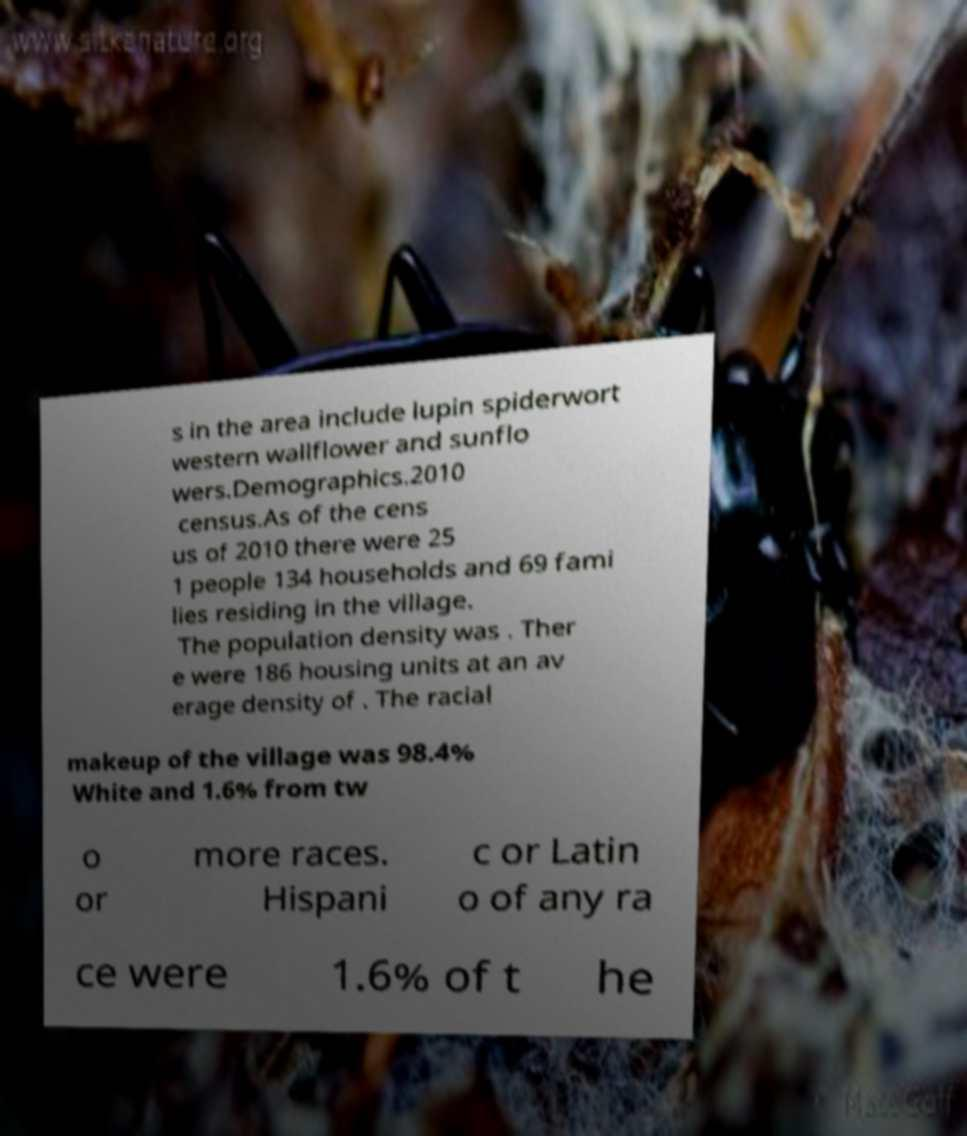Could you extract and type out the text from this image? s in the area include lupin spiderwort western wallflower and sunflo wers.Demographics.2010 census.As of the cens us of 2010 there were 25 1 people 134 households and 69 fami lies residing in the village. The population density was . Ther e were 186 housing units at an av erage density of . The racial makeup of the village was 98.4% White and 1.6% from tw o or more races. Hispani c or Latin o of any ra ce were 1.6% of t he 